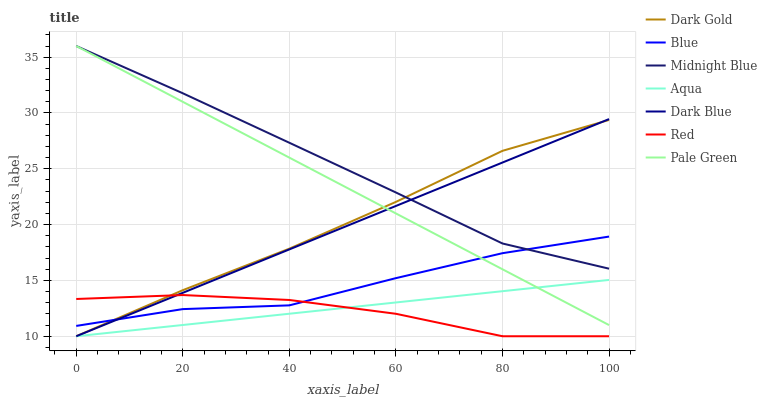Does Red have the minimum area under the curve?
Answer yes or no. Yes. Does Midnight Blue have the maximum area under the curve?
Answer yes or no. Yes. Does Dark Gold have the minimum area under the curve?
Answer yes or no. No. Does Dark Gold have the maximum area under the curve?
Answer yes or no. No. Is Aqua the smoothest?
Answer yes or no. Yes. Is Red the roughest?
Answer yes or no. Yes. Is Midnight Blue the smoothest?
Answer yes or no. No. Is Midnight Blue the roughest?
Answer yes or no. No. Does Dark Gold have the lowest value?
Answer yes or no. Yes. Does Midnight Blue have the lowest value?
Answer yes or no. No. Does Pale Green have the highest value?
Answer yes or no. Yes. Does Dark Gold have the highest value?
Answer yes or no. No. Is Aqua less than Midnight Blue?
Answer yes or no. Yes. Is Midnight Blue greater than Aqua?
Answer yes or no. Yes. Does Pale Green intersect Aqua?
Answer yes or no. Yes. Is Pale Green less than Aqua?
Answer yes or no. No. Is Pale Green greater than Aqua?
Answer yes or no. No. Does Aqua intersect Midnight Blue?
Answer yes or no. No. 